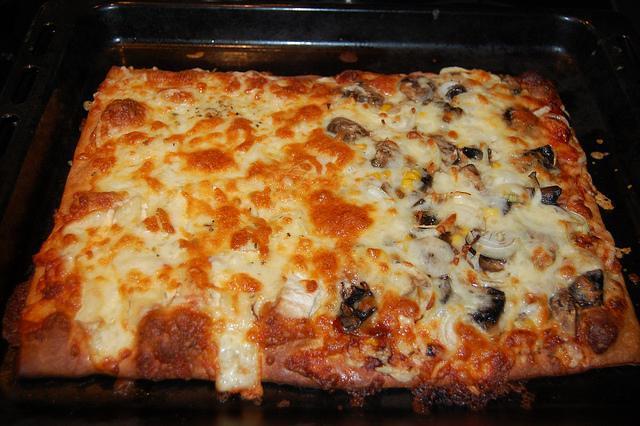How many people are there?
Give a very brief answer. 0. 